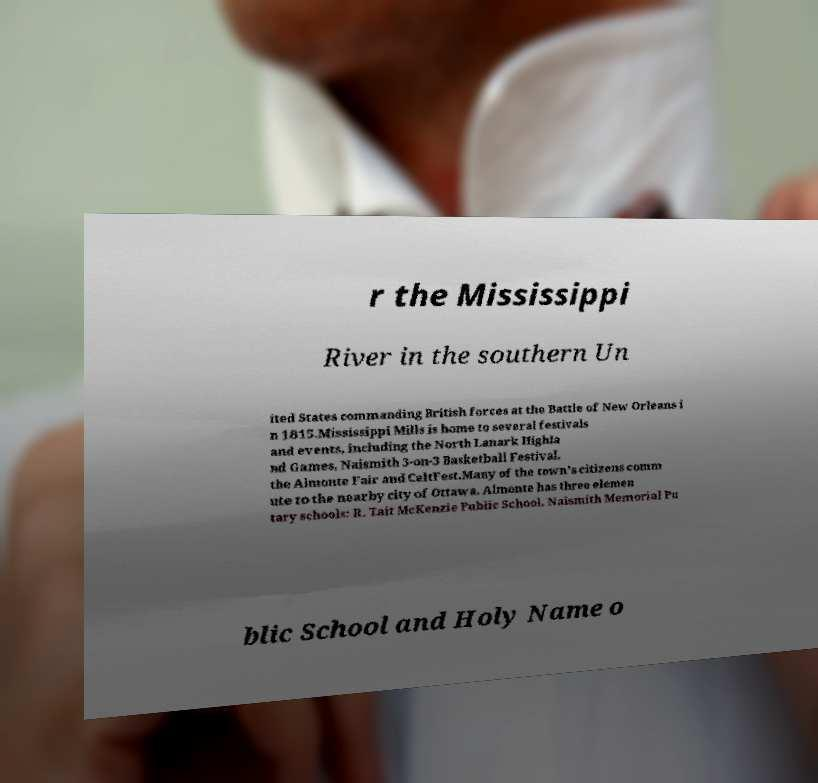Could you extract and type out the text from this image? r the Mississippi River in the southern Un ited States commanding British forces at the Battle of New Orleans i n 1815.Mississippi Mills is home to several festivals and events, including the North Lanark Highla nd Games, Naismith 3-on-3 Basketball Festival, the Almonte Fair and CeltFest.Many of the town's citizens comm ute to the nearby city of Ottawa. Almonte has three elemen tary schools: R. Tait McKenzie Public School, Naismith Memorial Pu blic School and Holy Name o 